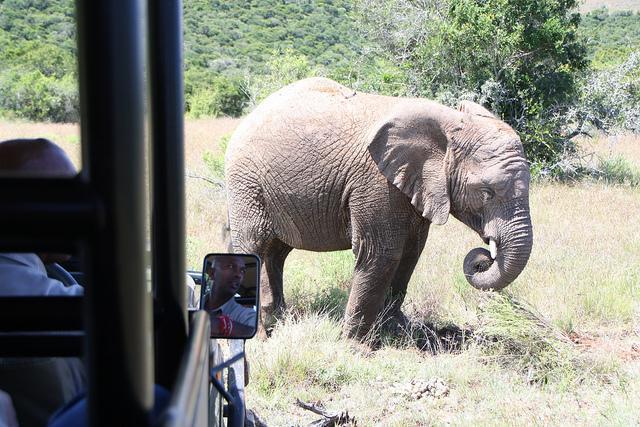Does the description: "The elephant is inside the truck." accurately reflect the image?
Answer yes or no. No. Evaluate: Does the caption "The truck is beside the elephant." match the image?
Answer yes or no. Yes. Is the statement "The truck is left of the elephant." accurate regarding the image?
Answer yes or no. Yes. Does the caption "The elephant is in front of the truck." correctly depict the image?
Answer yes or no. Yes. 